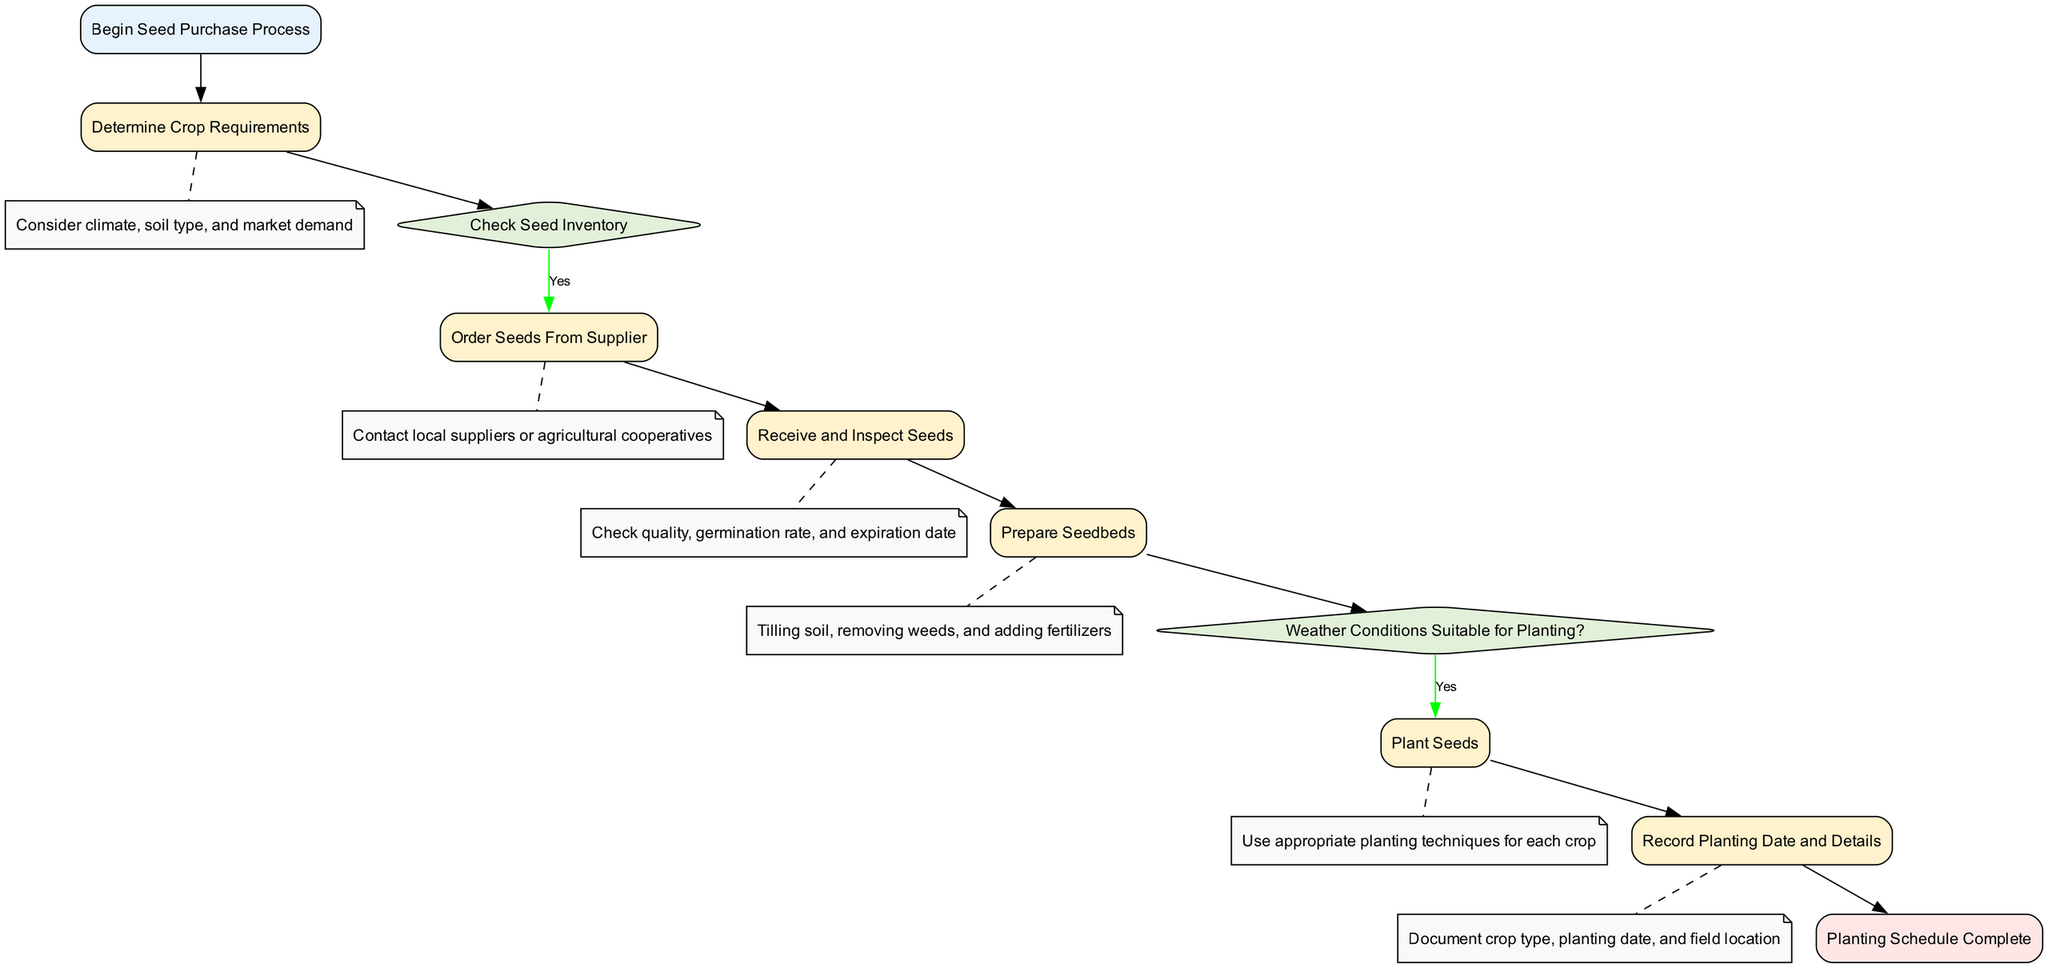What is the first step in the Seed Purchase Process? The first step in the flowchart is labeled "Begin Seed Purchase Process." This is indicated as the starting point of the diagram.
Answer: Begin Seed Purchase Process How many decision nodes are in the diagram? The flowchart contains two decision nodes, which are represented by diamond shapes. These nodes check for seed inventory and weather conditions.
Answer: 2 What happens if there are insufficient seeds? If the seed inventory check shows insufficient seeds, the flowchart leads to the "Order Seeds From Supplier" process. This process is triggered only if the seed inventory is not sufficient.
Answer: Order Seeds From Supplier What should be done before planting seeds? Before planting seeds, the flowchart indicates that one must check the weather conditions. If the conditions are suitable, one proceeds to the "Plant Seeds" process; otherwise, one must wait for suitable conditions.
Answer: Check Weather Conditions What details are recorded after planting? After planting seeds, the diagram states that one should "Record Planting Date and Details." This includes documenting the crop type, planting date, and field location following the planting action.
Answer: Record Planting Date and Details What is the last action in the flowchart? The final action in the flowchart is "Planting Schedule Complete." This indicates that the entire process of seed purchase and planting has concluded successfully.
Answer: Planting Schedule Complete What check occurs after determining crop requirements? After determining the crop requirements, the next step in the flowchart is checking the seed inventory. This decision node evaluates whether there are sufficient seeds available or not.
Answer: Check Seed Inventory What must happen if the weather conditions are not suitable for planting? If the weather conditions are not suitable for planting, the flowchart indicates that one must wait for suitable conditions before proceeding with the planting.
Answer: Wait for Suitable Conditions 